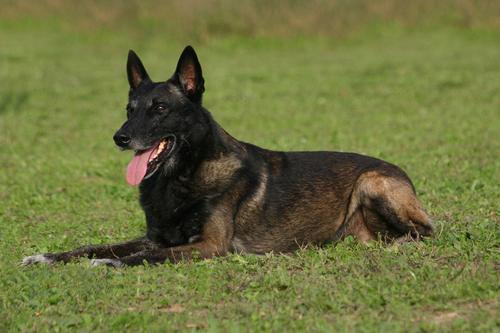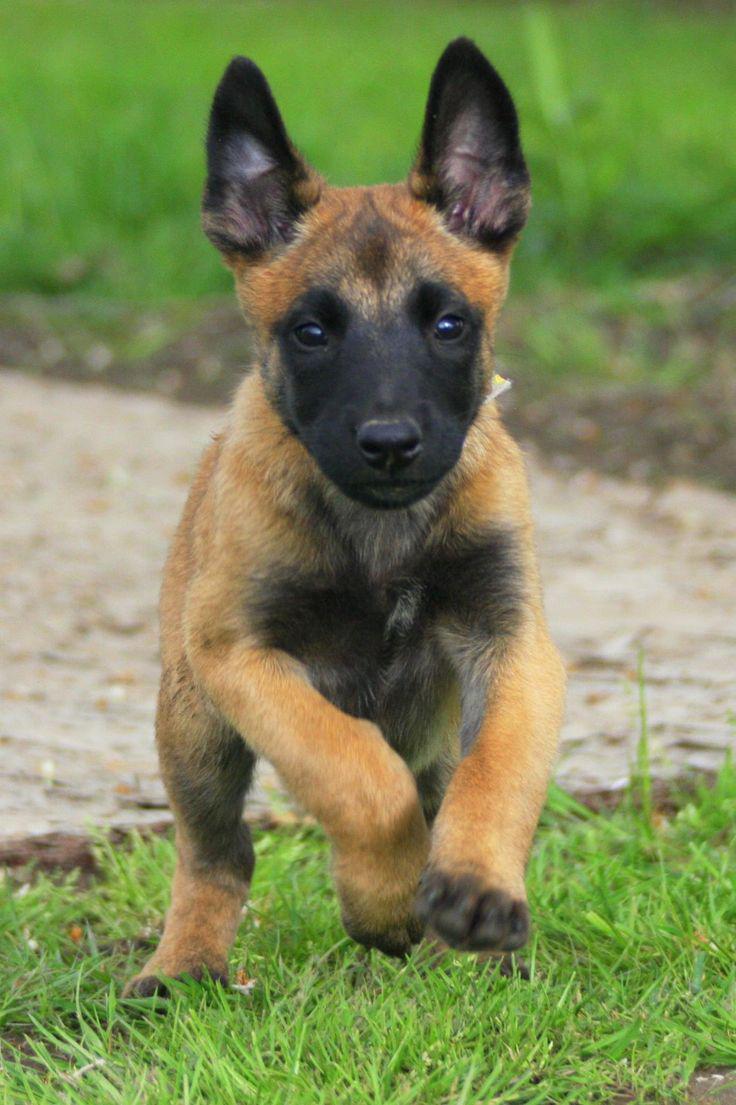The first image is the image on the left, the second image is the image on the right. For the images displayed, is the sentence "All dogs have their tongue sticking out." factually correct? Answer yes or no. No. 